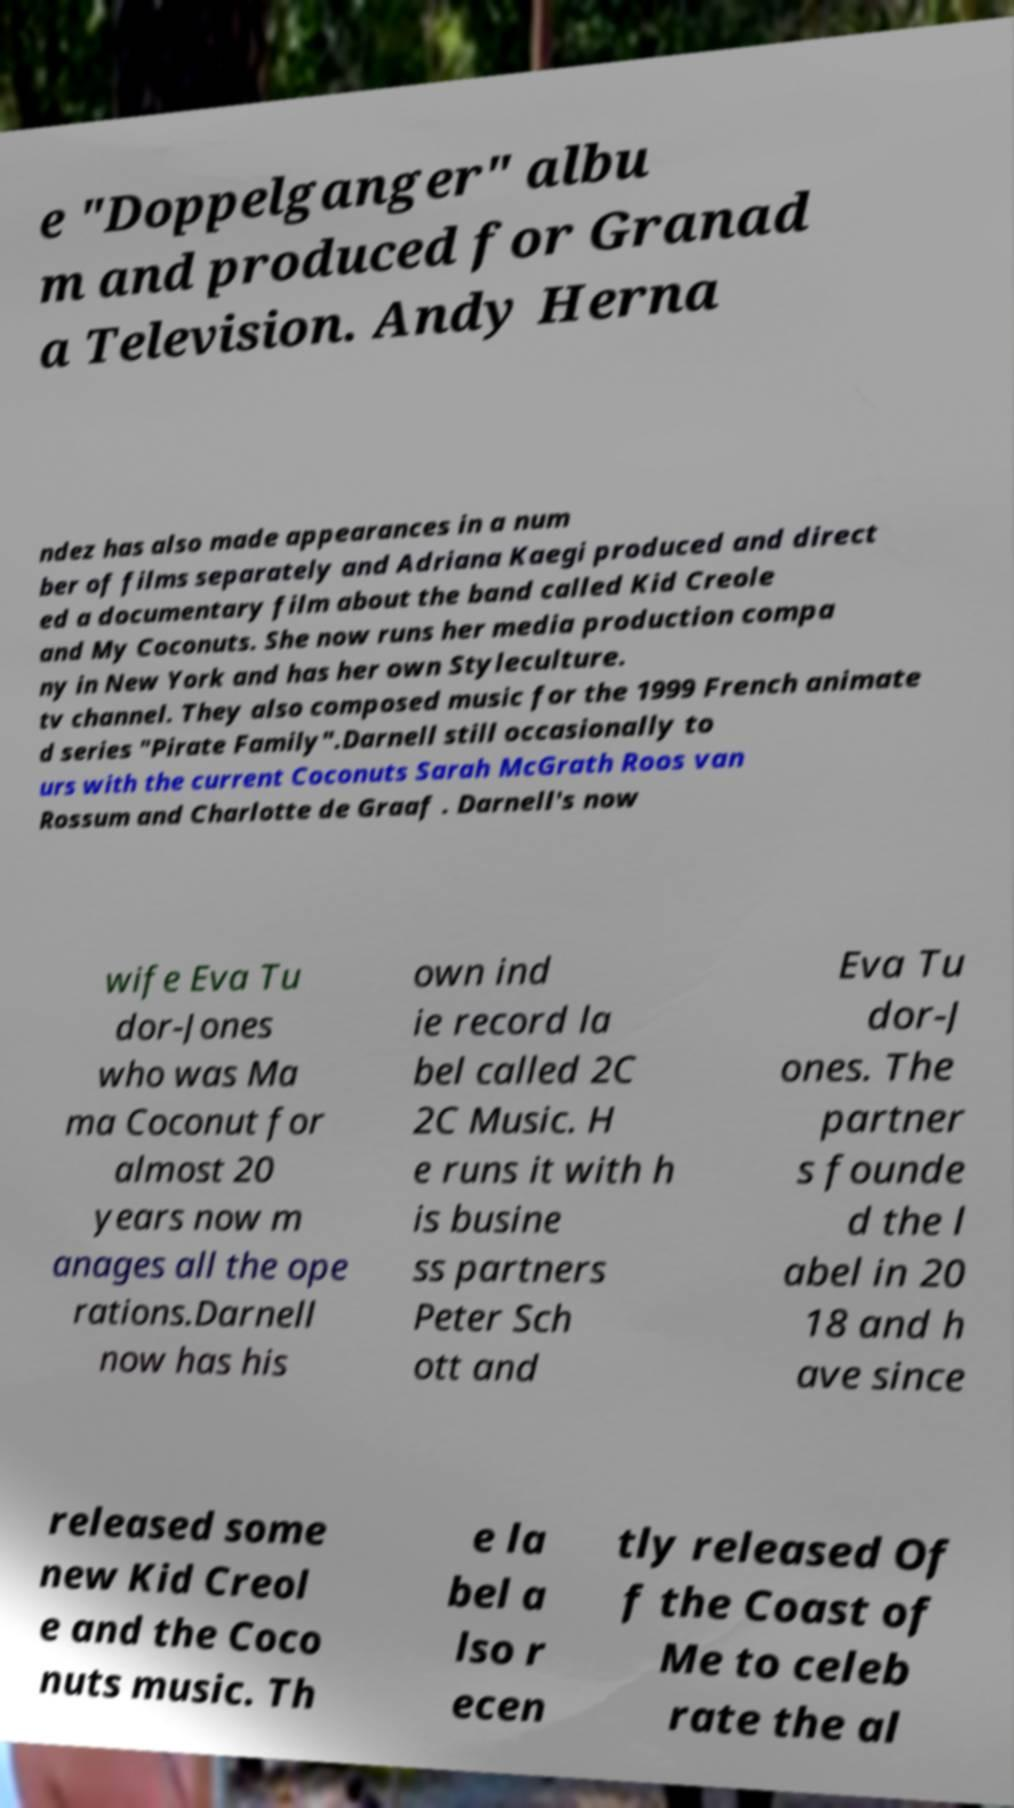Please read and relay the text visible in this image. What does it say? e "Doppelganger" albu m and produced for Granad a Television. Andy Herna ndez has also made appearances in a num ber of films separately and Adriana Kaegi produced and direct ed a documentary film about the band called Kid Creole and My Coconuts. She now runs her media production compa ny in New York and has her own Styleculture. tv channel. They also composed music for the 1999 French animate d series "Pirate Family".Darnell still occasionally to urs with the current Coconuts Sarah McGrath Roos van Rossum and Charlotte de Graaf . Darnell's now wife Eva Tu dor-Jones who was Ma ma Coconut for almost 20 years now m anages all the ope rations.Darnell now has his own ind ie record la bel called 2C 2C Music. H e runs it with h is busine ss partners Peter Sch ott and Eva Tu dor-J ones. The partner s founde d the l abel in 20 18 and h ave since released some new Kid Creol e and the Coco nuts music. Th e la bel a lso r ecen tly released Of f the Coast of Me to celeb rate the al 